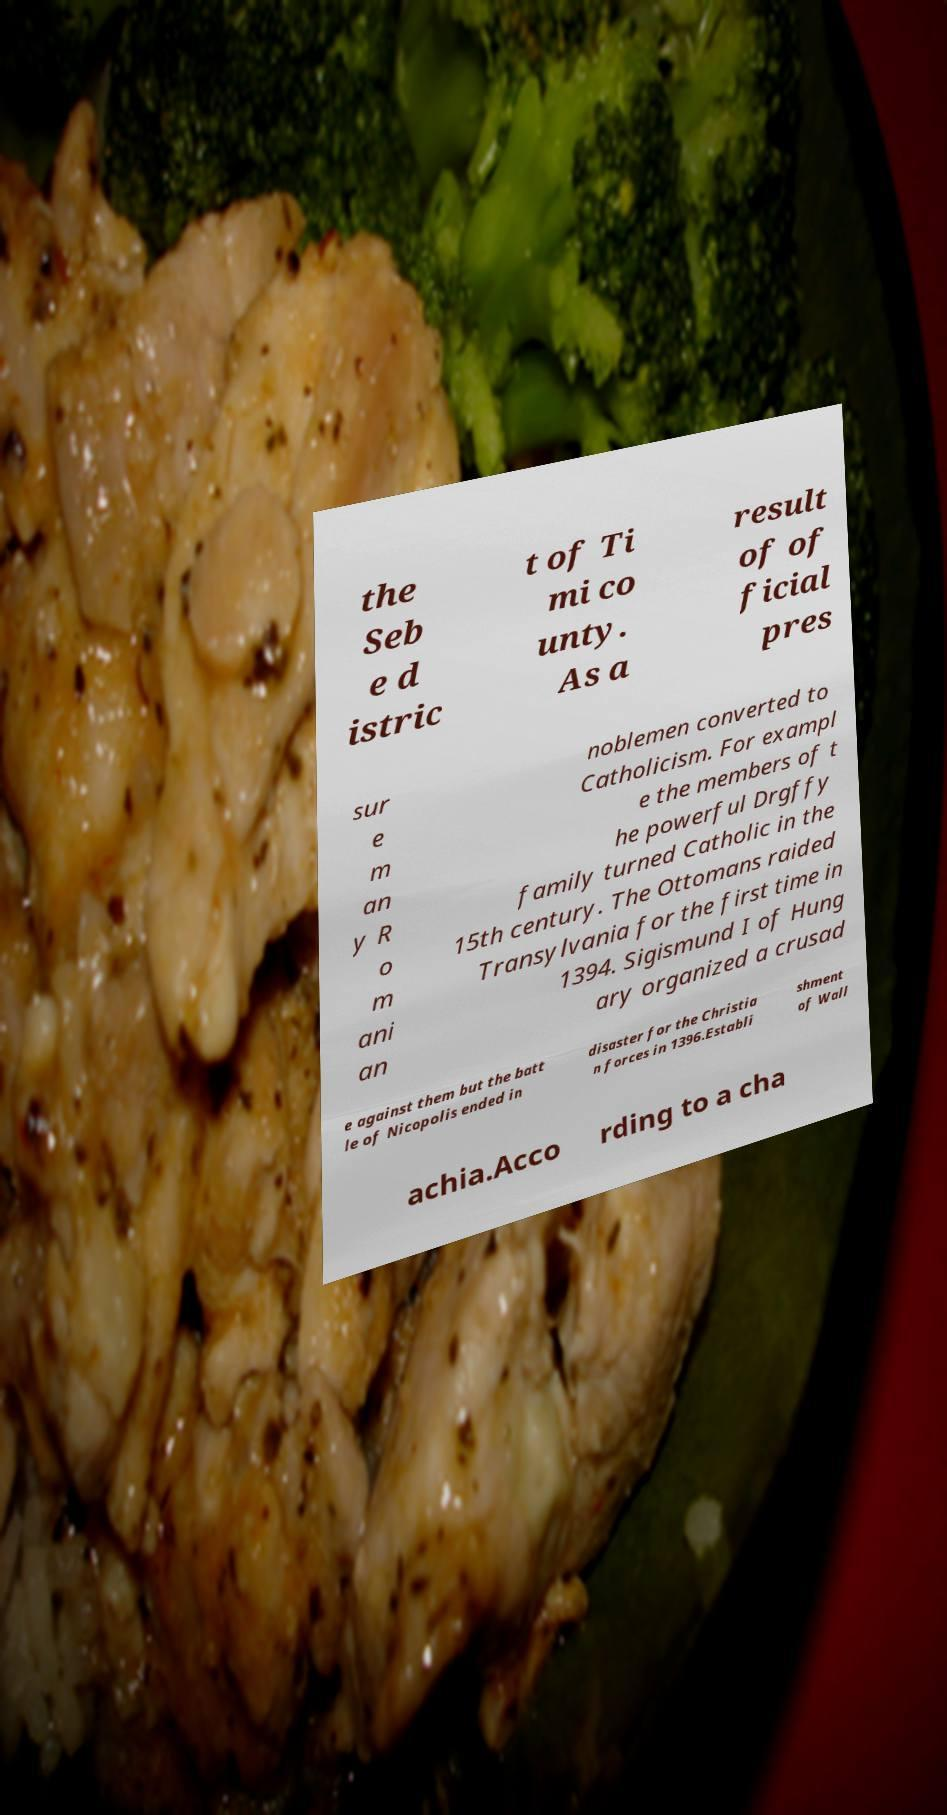I need the written content from this picture converted into text. Can you do that? the Seb e d istric t of Ti mi co unty. As a result of of ficial pres sur e m an y R o m ani an noblemen converted to Catholicism. For exampl e the members of t he powerful Drgffy family turned Catholic in the 15th century. The Ottomans raided Transylvania for the first time in 1394. Sigismund I of Hung ary organized a crusad e against them but the batt le of Nicopolis ended in disaster for the Christia n forces in 1396.Establi shment of Wall achia.Acco rding to a cha 